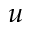Convert formula to latex. <formula><loc_0><loc_0><loc_500><loc_500>u</formula> 